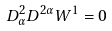Convert formula to latex. <formula><loc_0><loc_0><loc_500><loc_500>D ^ { 2 } _ { \alpha } D ^ { 2 \alpha } W ^ { 1 } = 0</formula> 